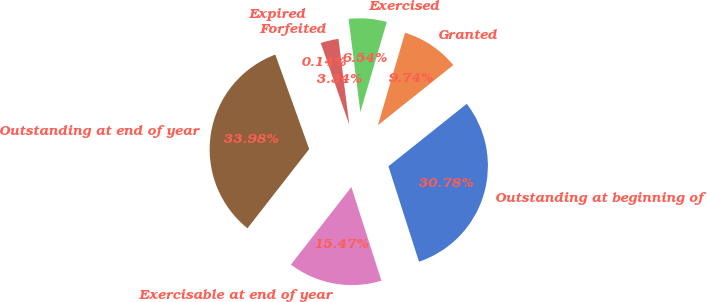Convert chart to OTSL. <chart><loc_0><loc_0><loc_500><loc_500><pie_chart><fcel>Outstanding at beginning of<fcel>Granted<fcel>Exercised<fcel>Forfeited<fcel>Expired<fcel>Outstanding at end of year<fcel>Exercisable at end of year<nl><fcel>30.78%<fcel>9.74%<fcel>6.54%<fcel>3.34%<fcel>0.14%<fcel>33.98%<fcel>15.47%<nl></chart> 